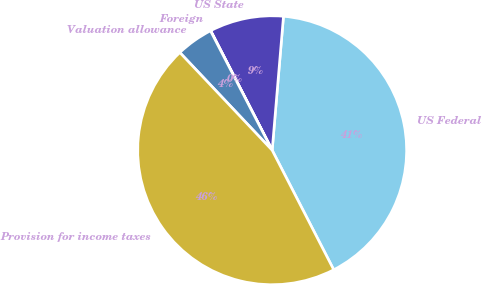Convert chart. <chart><loc_0><loc_0><loc_500><loc_500><pie_chart><fcel>US Federal<fcel>US State<fcel>Foreign<fcel>Valuation allowance<fcel>Provision for income taxes<nl><fcel>41.09%<fcel>8.9%<fcel>0.03%<fcel>4.46%<fcel>45.52%<nl></chart> 